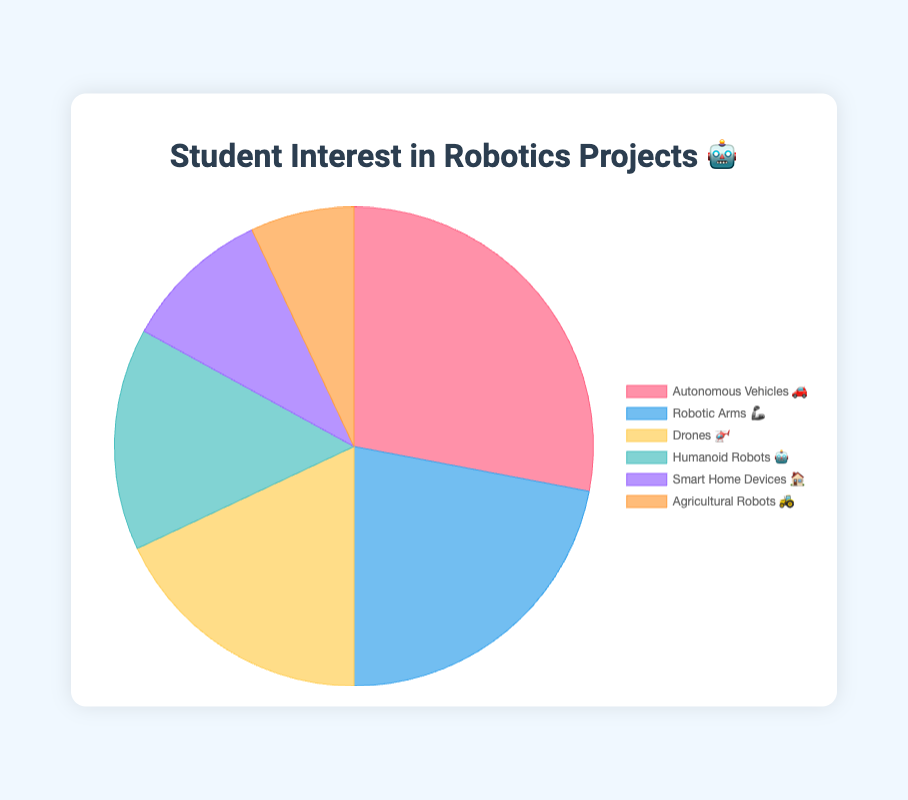Which project category has the highest student interest? The chart shows that the category with the highest numerical value of interest is "Autonomous Vehicles 🚗"
Answer: Autonomous Vehicles🚗 Which category has the least interest among students? By looking at the values for each category, "Agricultural Robots 🚜" has the lowest interest level at 7%
Answer: Agricultural Robots🚜 What is the total percentage of interest in "Robotic Arms 🦾" and "Drones 🚁"? Sum the interest percentages of "Robotic Arms 🦾" and "Drones 🚁" which are 22% and 18% respectively
Answer: 40% How does the interest in "Humanoid Robots 🤖" compare to "Smart Home Devices 🏠"? The interest in "Humanoid Robots 🤖" is 15% while the interest in "Smart Home Devices 🏠" is 10%, making "Humanoid Robots 🤖" 5% higher
Answer: Humanoid Robots🤖 What is the average interest percentage across all categories? Sum all category interests (28 + 22 + 18 + 15 + 10 + 7 = 100) and divide by the number of categories (6) to get the average
Answer: 16.67% What is the difference in interest between the two most popular categories? The two most popular categories are "Autonomous Vehicles 🚗" (28%) and "Robotic Arms 🦾" (22%) making the difference 28 - 22
Answer: 6% Which category has an interest percentage exactly half of "Autonomous Vehicles 🚗"? "Autonomous Vehicles 🚗" has 28%, half of which is 14%. Since "Humanoid Robots 🤖" has 15%, there is no exact match but "Humanoid Robots 🤖" is the closest
Answer: None What is the combined interest percentage of the least three popular categories? The interests are 15% for "Humanoid Robots 🤖", 10% for "Smart Home Devices 🏠", and 7% for "Agricultural Robots 🚜". Summing these gives 15 + 10 + 7
Answer: 32% 